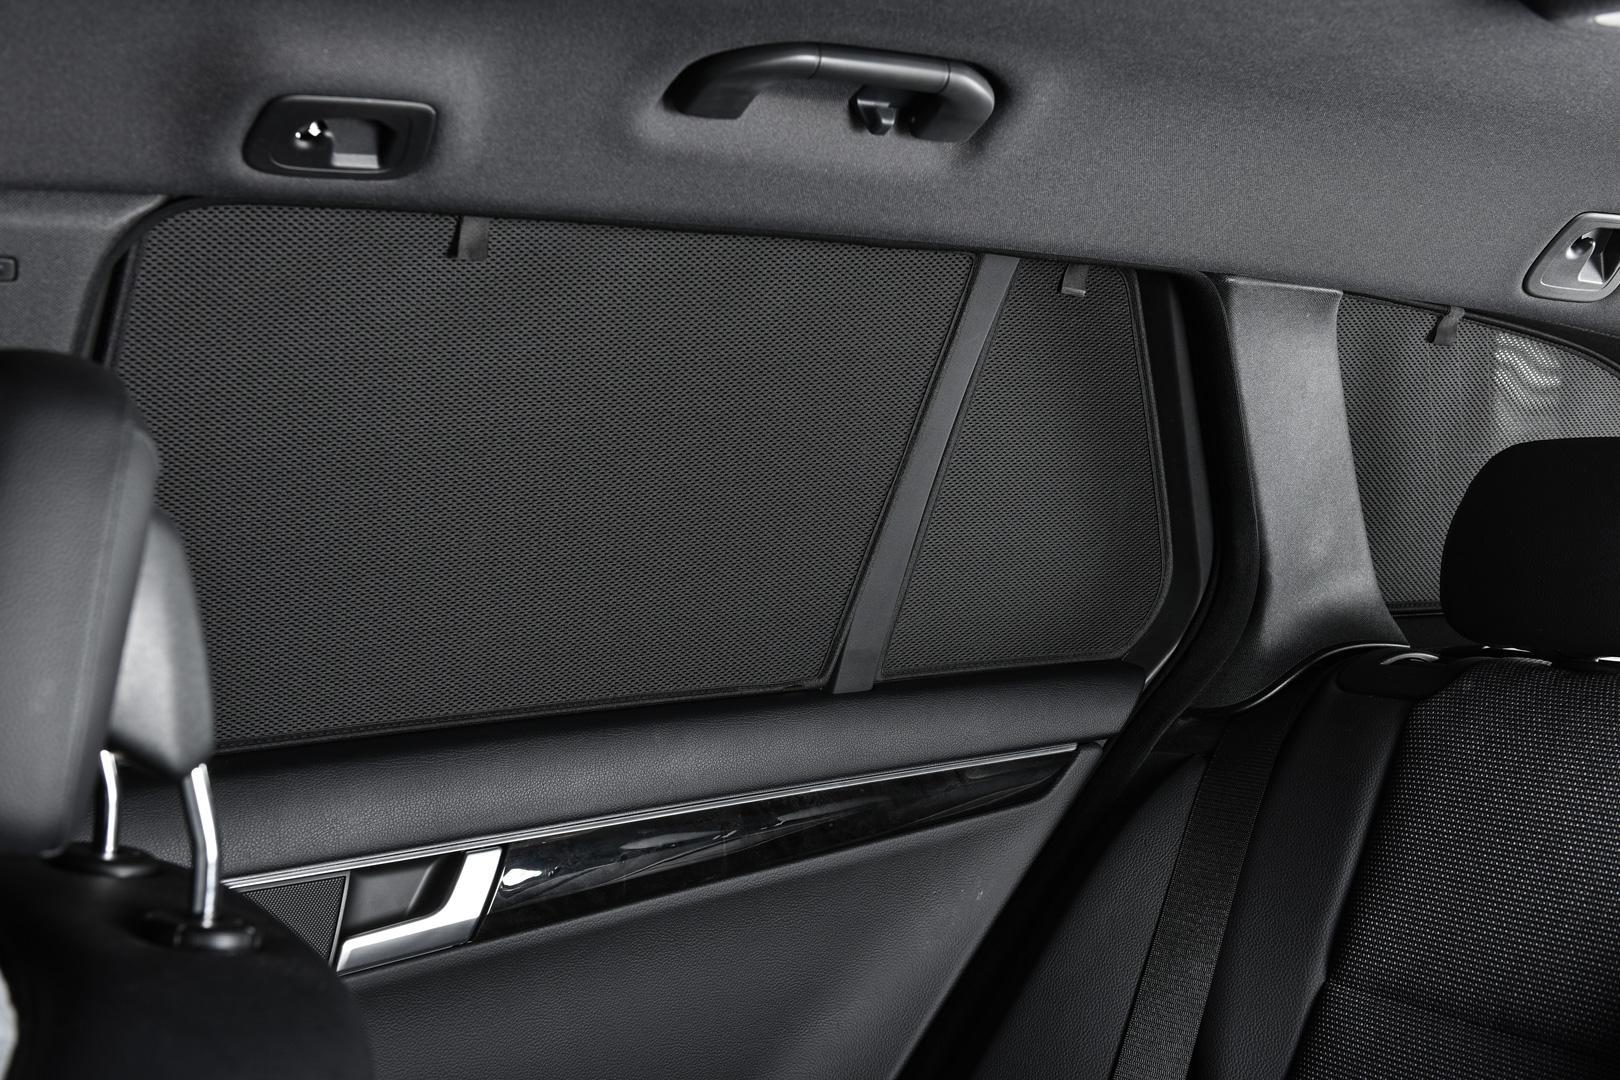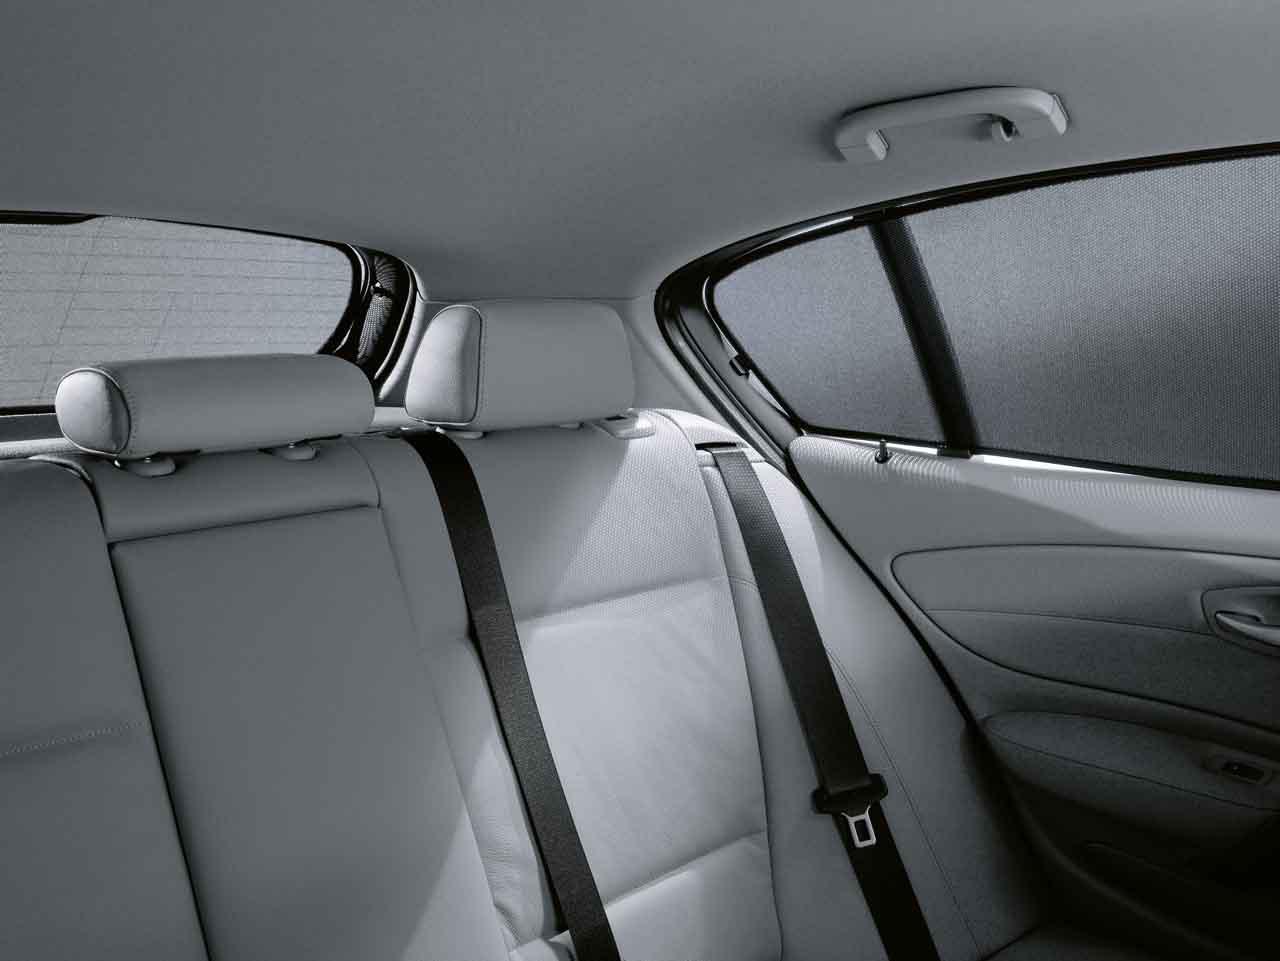The first image is the image on the left, the second image is the image on the right. Examine the images to the left and right. Is the description "The car door is ajar in one of the images." accurate? Answer yes or no. No. 